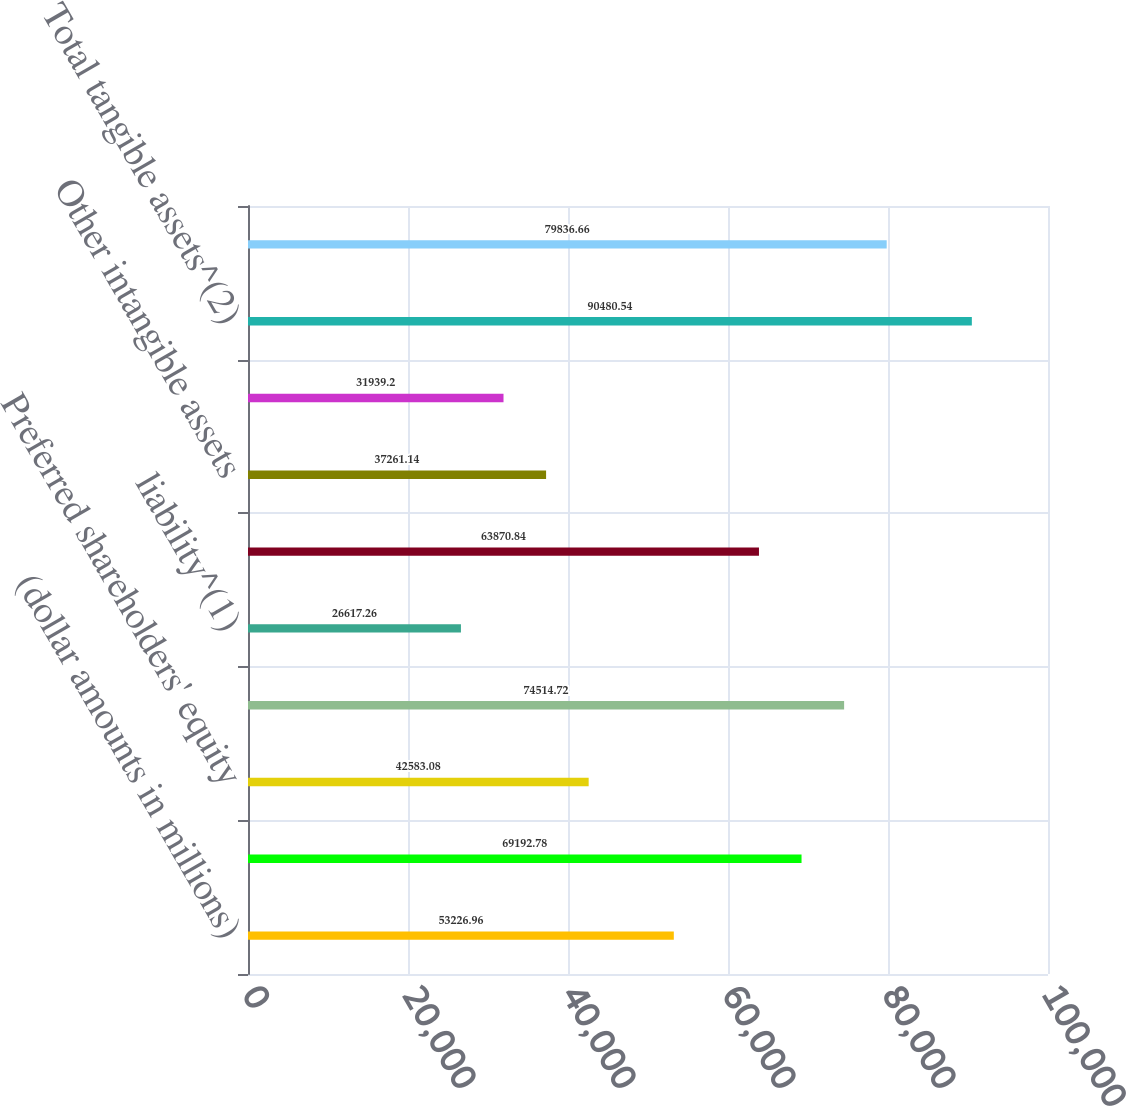Convert chart. <chart><loc_0><loc_0><loc_500><loc_500><bar_chart><fcel>(dollar amounts in millions)<fcel>Common shareholders' equity<fcel>Preferred shareholders' equity<fcel>Total shareholders' equity<fcel>liability^(1)<fcel>Total tangible equity^(2)<fcel>Other intangible assets<fcel>Other intangible asset<fcel>Total tangible assets^(2)<fcel>Tier 1 capital<nl><fcel>53227<fcel>69192.8<fcel>42583.1<fcel>74514.7<fcel>26617.3<fcel>63870.8<fcel>37261.1<fcel>31939.2<fcel>90480.5<fcel>79836.7<nl></chart> 